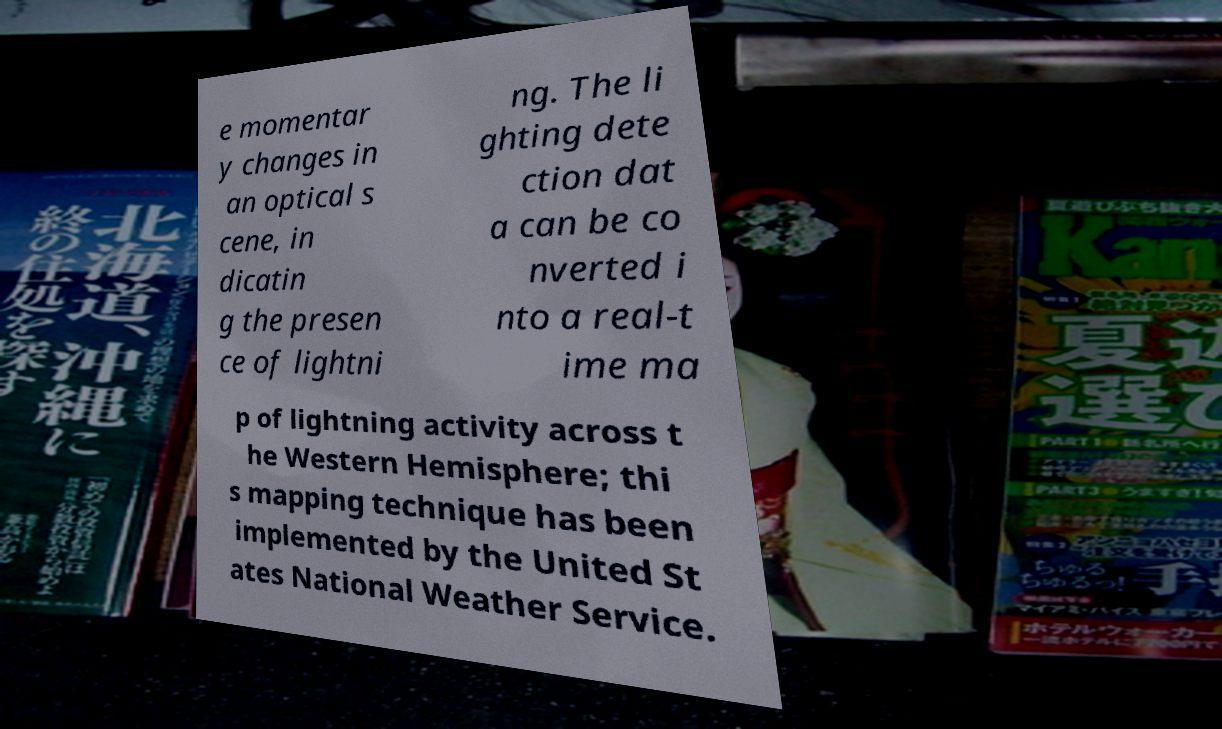Please identify and transcribe the text found in this image. e momentar y changes in an optical s cene, in dicatin g the presen ce of lightni ng. The li ghting dete ction dat a can be co nverted i nto a real-t ime ma p of lightning activity across t he Western Hemisphere; thi s mapping technique has been implemented by the United St ates National Weather Service. 